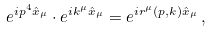<formula> <loc_0><loc_0><loc_500><loc_500>e ^ { i p ^ { 4 } \hat { x } _ { \mu } } \cdot e ^ { i k ^ { \mu } \hat { x } _ { \mu } } = e ^ { i r ^ { \mu } ( p , k ) \hat { x } _ { \mu } } \, ,</formula> 